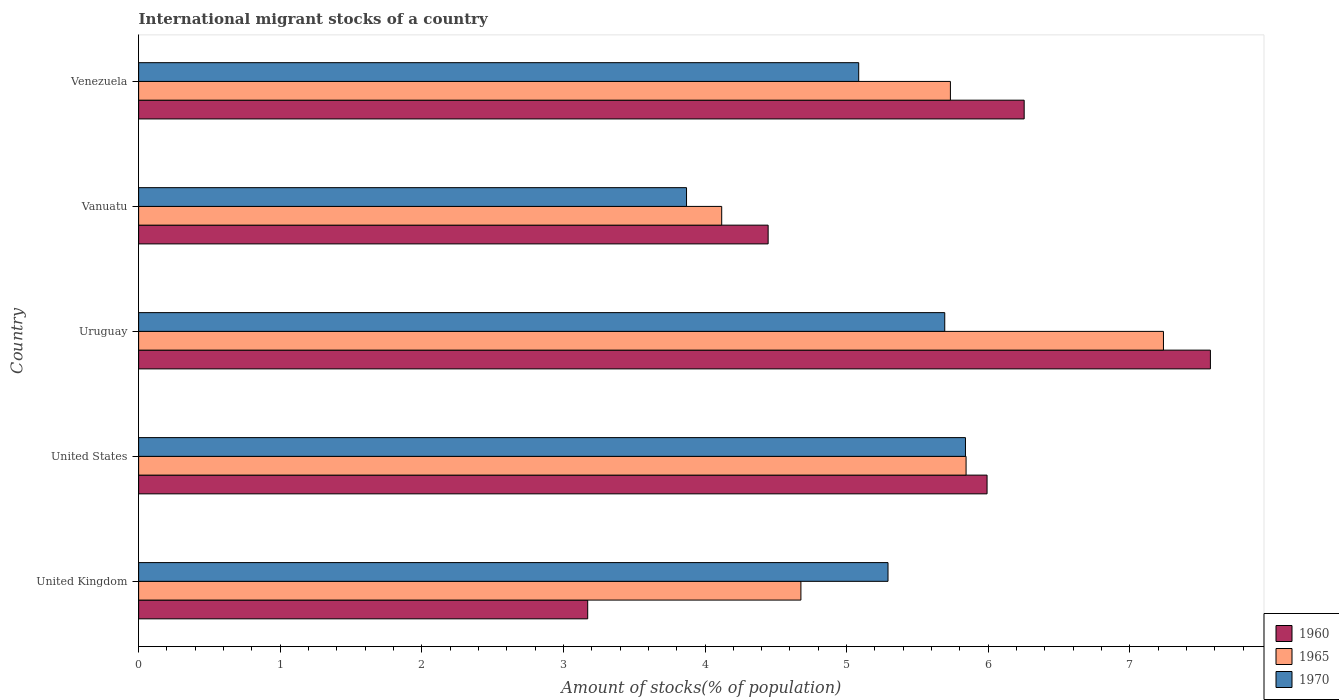How many different coloured bars are there?
Your answer should be very brief. 3. Are the number of bars per tick equal to the number of legend labels?
Your response must be concise. Yes. What is the label of the 5th group of bars from the top?
Offer a terse response. United Kingdom. What is the amount of stocks in in 1970 in Venezuela?
Your answer should be very brief. 5.09. Across all countries, what is the maximum amount of stocks in in 1960?
Keep it short and to the point. 7.57. Across all countries, what is the minimum amount of stocks in in 1965?
Offer a terse response. 4.12. In which country was the amount of stocks in in 1960 maximum?
Make the answer very short. Uruguay. In which country was the amount of stocks in in 1965 minimum?
Provide a succinct answer. Vanuatu. What is the total amount of stocks in in 1960 in the graph?
Make the answer very short. 27.43. What is the difference between the amount of stocks in in 1970 in United Kingdom and that in United States?
Give a very brief answer. -0.55. What is the difference between the amount of stocks in in 1965 in United Kingdom and the amount of stocks in in 1970 in Venezuela?
Your answer should be compact. -0.41. What is the average amount of stocks in in 1970 per country?
Provide a short and direct response. 5.16. What is the difference between the amount of stocks in in 1960 and amount of stocks in in 1970 in United States?
Keep it short and to the point. 0.15. In how many countries, is the amount of stocks in in 1965 greater than 0.6000000000000001 %?
Make the answer very short. 5. What is the ratio of the amount of stocks in in 1965 in United States to that in Uruguay?
Make the answer very short. 0.81. What is the difference between the highest and the second highest amount of stocks in in 1960?
Offer a very short reply. 1.32. What is the difference between the highest and the lowest amount of stocks in in 1960?
Keep it short and to the point. 4.4. In how many countries, is the amount of stocks in in 1965 greater than the average amount of stocks in in 1965 taken over all countries?
Your response must be concise. 3. Is the sum of the amount of stocks in in 1965 in United Kingdom and Venezuela greater than the maximum amount of stocks in in 1970 across all countries?
Provide a succinct answer. Yes. What does the 2nd bar from the top in Venezuela represents?
Provide a succinct answer. 1965. What does the 3rd bar from the bottom in Vanuatu represents?
Keep it short and to the point. 1970. Is it the case that in every country, the sum of the amount of stocks in in 1965 and amount of stocks in in 1970 is greater than the amount of stocks in in 1960?
Keep it short and to the point. Yes. How many countries are there in the graph?
Provide a succinct answer. 5. What is the difference between two consecutive major ticks on the X-axis?
Give a very brief answer. 1. Does the graph contain grids?
Your answer should be compact. No. What is the title of the graph?
Provide a short and direct response. International migrant stocks of a country. Does "2004" appear as one of the legend labels in the graph?
Provide a short and direct response. No. What is the label or title of the X-axis?
Provide a short and direct response. Amount of stocks(% of population). What is the label or title of the Y-axis?
Your answer should be very brief. Country. What is the Amount of stocks(% of population) in 1960 in United Kingdom?
Your response must be concise. 3.17. What is the Amount of stocks(% of population) of 1965 in United Kingdom?
Your response must be concise. 4.68. What is the Amount of stocks(% of population) in 1970 in United Kingdom?
Ensure brevity in your answer.  5.29. What is the Amount of stocks(% of population) of 1960 in United States?
Your answer should be very brief. 5.99. What is the Amount of stocks(% of population) of 1965 in United States?
Keep it short and to the point. 5.84. What is the Amount of stocks(% of population) in 1970 in United States?
Offer a terse response. 5.84. What is the Amount of stocks(% of population) in 1960 in Uruguay?
Ensure brevity in your answer.  7.57. What is the Amount of stocks(% of population) in 1965 in Uruguay?
Keep it short and to the point. 7.24. What is the Amount of stocks(% of population) of 1970 in Uruguay?
Offer a very short reply. 5.69. What is the Amount of stocks(% of population) of 1960 in Vanuatu?
Make the answer very short. 4.45. What is the Amount of stocks(% of population) of 1965 in Vanuatu?
Ensure brevity in your answer.  4.12. What is the Amount of stocks(% of population) of 1970 in Vanuatu?
Your answer should be compact. 3.87. What is the Amount of stocks(% of population) in 1960 in Venezuela?
Ensure brevity in your answer.  6.25. What is the Amount of stocks(% of population) of 1965 in Venezuela?
Offer a terse response. 5.73. What is the Amount of stocks(% of population) in 1970 in Venezuela?
Your answer should be very brief. 5.09. Across all countries, what is the maximum Amount of stocks(% of population) of 1960?
Your answer should be compact. 7.57. Across all countries, what is the maximum Amount of stocks(% of population) in 1965?
Your response must be concise. 7.24. Across all countries, what is the maximum Amount of stocks(% of population) of 1970?
Provide a succinct answer. 5.84. Across all countries, what is the minimum Amount of stocks(% of population) in 1960?
Make the answer very short. 3.17. Across all countries, what is the minimum Amount of stocks(% of population) in 1965?
Your answer should be compact. 4.12. Across all countries, what is the minimum Amount of stocks(% of population) of 1970?
Make the answer very short. 3.87. What is the total Amount of stocks(% of population) of 1960 in the graph?
Provide a short and direct response. 27.43. What is the total Amount of stocks(% of population) in 1965 in the graph?
Offer a terse response. 27.61. What is the total Amount of stocks(% of population) of 1970 in the graph?
Your response must be concise. 25.78. What is the difference between the Amount of stocks(% of population) in 1960 in United Kingdom and that in United States?
Your answer should be very brief. -2.82. What is the difference between the Amount of stocks(% of population) in 1965 in United Kingdom and that in United States?
Offer a very short reply. -1.17. What is the difference between the Amount of stocks(% of population) of 1970 in United Kingdom and that in United States?
Your response must be concise. -0.55. What is the difference between the Amount of stocks(% of population) in 1960 in United Kingdom and that in Uruguay?
Keep it short and to the point. -4.4. What is the difference between the Amount of stocks(% of population) in 1965 in United Kingdom and that in Uruguay?
Offer a terse response. -2.56. What is the difference between the Amount of stocks(% of population) of 1970 in United Kingdom and that in Uruguay?
Provide a short and direct response. -0.4. What is the difference between the Amount of stocks(% of population) in 1960 in United Kingdom and that in Vanuatu?
Your answer should be very brief. -1.27. What is the difference between the Amount of stocks(% of population) of 1965 in United Kingdom and that in Vanuatu?
Give a very brief answer. 0.56. What is the difference between the Amount of stocks(% of population) of 1970 in United Kingdom and that in Vanuatu?
Your response must be concise. 1.42. What is the difference between the Amount of stocks(% of population) in 1960 in United Kingdom and that in Venezuela?
Give a very brief answer. -3.08. What is the difference between the Amount of stocks(% of population) in 1965 in United Kingdom and that in Venezuela?
Your response must be concise. -1.06. What is the difference between the Amount of stocks(% of population) of 1970 in United Kingdom and that in Venezuela?
Make the answer very short. 0.21. What is the difference between the Amount of stocks(% of population) in 1960 in United States and that in Uruguay?
Your response must be concise. -1.58. What is the difference between the Amount of stocks(% of population) of 1965 in United States and that in Uruguay?
Give a very brief answer. -1.39. What is the difference between the Amount of stocks(% of population) of 1970 in United States and that in Uruguay?
Make the answer very short. 0.15. What is the difference between the Amount of stocks(% of population) in 1960 in United States and that in Vanuatu?
Keep it short and to the point. 1.55. What is the difference between the Amount of stocks(% of population) in 1965 in United States and that in Vanuatu?
Ensure brevity in your answer.  1.73. What is the difference between the Amount of stocks(% of population) in 1970 in United States and that in Vanuatu?
Provide a short and direct response. 1.97. What is the difference between the Amount of stocks(% of population) of 1960 in United States and that in Venezuela?
Keep it short and to the point. -0.26. What is the difference between the Amount of stocks(% of population) of 1965 in United States and that in Venezuela?
Provide a succinct answer. 0.11. What is the difference between the Amount of stocks(% of population) in 1970 in United States and that in Venezuela?
Offer a terse response. 0.75. What is the difference between the Amount of stocks(% of population) of 1960 in Uruguay and that in Vanuatu?
Make the answer very short. 3.12. What is the difference between the Amount of stocks(% of population) in 1965 in Uruguay and that in Vanuatu?
Give a very brief answer. 3.12. What is the difference between the Amount of stocks(% of population) of 1970 in Uruguay and that in Vanuatu?
Ensure brevity in your answer.  1.82. What is the difference between the Amount of stocks(% of population) in 1960 in Uruguay and that in Venezuela?
Keep it short and to the point. 1.32. What is the difference between the Amount of stocks(% of population) of 1965 in Uruguay and that in Venezuela?
Ensure brevity in your answer.  1.5. What is the difference between the Amount of stocks(% of population) of 1970 in Uruguay and that in Venezuela?
Your response must be concise. 0.61. What is the difference between the Amount of stocks(% of population) of 1960 in Vanuatu and that in Venezuela?
Ensure brevity in your answer.  -1.81. What is the difference between the Amount of stocks(% of population) in 1965 in Vanuatu and that in Venezuela?
Your answer should be compact. -1.62. What is the difference between the Amount of stocks(% of population) in 1970 in Vanuatu and that in Venezuela?
Provide a short and direct response. -1.22. What is the difference between the Amount of stocks(% of population) of 1960 in United Kingdom and the Amount of stocks(% of population) of 1965 in United States?
Ensure brevity in your answer.  -2.67. What is the difference between the Amount of stocks(% of population) in 1960 in United Kingdom and the Amount of stocks(% of population) in 1970 in United States?
Keep it short and to the point. -2.67. What is the difference between the Amount of stocks(% of population) of 1965 in United Kingdom and the Amount of stocks(% of population) of 1970 in United States?
Your response must be concise. -1.16. What is the difference between the Amount of stocks(% of population) of 1960 in United Kingdom and the Amount of stocks(% of population) of 1965 in Uruguay?
Your answer should be very brief. -4.07. What is the difference between the Amount of stocks(% of population) of 1960 in United Kingdom and the Amount of stocks(% of population) of 1970 in Uruguay?
Your response must be concise. -2.52. What is the difference between the Amount of stocks(% of population) in 1965 in United Kingdom and the Amount of stocks(% of population) in 1970 in Uruguay?
Offer a very short reply. -1.02. What is the difference between the Amount of stocks(% of population) of 1960 in United Kingdom and the Amount of stocks(% of population) of 1965 in Vanuatu?
Provide a succinct answer. -0.95. What is the difference between the Amount of stocks(% of population) of 1960 in United Kingdom and the Amount of stocks(% of population) of 1970 in Vanuatu?
Your answer should be compact. -0.7. What is the difference between the Amount of stocks(% of population) in 1965 in United Kingdom and the Amount of stocks(% of population) in 1970 in Vanuatu?
Your answer should be compact. 0.81. What is the difference between the Amount of stocks(% of population) of 1960 in United Kingdom and the Amount of stocks(% of population) of 1965 in Venezuela?
Make the answer very short. -2.56. What is the difference between the Amount of stocks(% of population) of 1960 in United Kingdom and the Amount of stocks(% of population) of 1970 in Venezuela?
Keep it short and to the point. -1.91. What is the difference between the Amount of stocks(% of population) in 1965 in United Kingdom and the Amount of stocks(% of population) in 1970 in Venezuela?
Keep it short and to the point. -0.41. What is the difference between the Amount of stocks(% of population) in 1960 in United States and the Amount of stocks(% of population) in 1965 in Uruguay?
Provide a succinct answer. -1.25. What is the difference between the Amount of stocks(% of population) of 1960 in United States and the Amount of stocks(% of population) of 1970 in Uruguay?
Your answer should be very brief. 0.3. What is the difference between the Amount of stocks(% of population) in 1965 in United States and the Amount of stocks(% of population) in 1970 in Uruguay?
Offer a terse response. 0.15. What is the difference between the Amount of stocks(% of population) in 1960 in United States and the Amount of stocks(% of population) in 1965 in Vanuatu?
Your response must be concise. 1.87. What is the difference between the Amount of stocks(% of population) of 1960 in United States and the Amount of stocks(% of population) of 1970 in Vanuatu?
Your answer should be very brief. 2.12. What is the difference between the Amount of stocks(% of population) of 1965 in United States and the Amount of stocks(% of population) of 1970 in Vanuatu?
Make the answer very short. 1.97. What is the difference between the Amount of stocks(% of population) in 1960 in United States and the Amount of stocks(% of population) in 1965 in Venezuela?
Provide a short and direct response. 0.26. What is the difference between the Amount of stocks(% of population) in 1960 in United States and the Amount of stocks(% of population) in 1970 in Venezuela?
Keep it short and to the point. 0.91. What is the difference between the Amount of stocks(% of population) in 1965 in United States and the Amount of stocks(% of population) in 1970 in Venezuela?
Your response must be concise. 0.76. What is the difference between the Amount of stocks(% of population) of 1960 in Uruguay and the Amount of stocks(% of population) of 1965 in Vanuatu?
Your response must be concise. 3.45. What is the difference between the Amount of stocks(% of population) in 1960 in Uruguay and the Amount of stocks(% of population) in 1970 in Vanuatu?
Ensure brevity in your answer.  3.7. What is the difference between the Amount of stocks(% of population) of 1965 in Uruguay and the Amount of stocks(% of population) of 1970 in Vanuatu?
Provide a succinct answer. 3.37. What is the difference between the Amount of stocks(% of population) in 1960 in Uruguay and the Amount of stocks(% of population) in 1965 in Venezuela?
Your answer should be compact. 1.84. What is the difference between the Amount of stocks(% of population) in 1960 in Uruguay and the Amount of stocks(% of population) in 1970 in Venezuela?
Ensure brevity in your answer.  2.48. What is the difference between the Amount of stocks(% of population) of 1965 in Uruguay and the Amount of stocks(% of population) of 1970 in Venezuela?
Your answer should be very brief. 2.15. What is the difference between the Amount of stocks(% of population) in 1960 in Vanuatu and the Amount of stocks(% of population) in 1965 in Venezuela?
Offer a terse response. -1.29. What is the difference between the Amount of stocks(% of population) of 1960 in Vanuatu and the Amount of stocks(% of population) of 1970 in Venezuela?
Make the answer very short. -0.64. What is the difference between the Amount of stocks(% of population) in 1965 in Vanuatu and the Amount of stocks(% of population) in 1970 in Venezuela?
Offer a very short reply. -0.97. What is the average Amount of stocks(% of population) in 1960 per country?
Offer a very short reply. 5.49. What is the average Amount of stocks(% of population) of 1965 per country?
Your answer should be compact. 5.52. What is the average Amount of stocks(% of population) of 1970 per country?
Your response must be concise. 5.16. What is the difference between the Amount of stocks(% of population) of 1960 and Amount of stocks(% of population) of 1965 in United Kingdom?
Provide a short and direct response. -1.51. What is the difference between the Amount of stocks(% of population) of 1960 and Amount of stocks(% of population) of 1970 in United Kingdom?
Give a very brief answer. -2.12. What is the difference between the Amount of stocks(% of population) of 1965 and Amount of stocks(% of population) of 1970 in United Kingdom?
Offer a very short reply. -0.62. What is the difference between the Amount of stocks(% of population) of 1960 and Amount of stocks(% of population) of 1965 in United States?
Your answer should be compact. 0.15. What is the difference between the Amount of stocks(% of population) of 1960 and Amount of stocks(% of population) of 1970 in United States?
Offer a terse response. 0.15. What is the difference between the Amount of stocks(% of population) in 1965 and Amount of stocks(% of population) in 1970 in United States?
Keep it short and to the point. 0. What is the difference between the Amount of stocks(% of population) in 1960 and Amount of stocks(% of population) in 1965 in Uruguay?
Provide a succinct answer. 0.33. What is the difference between the Amount of stocks(% of population) of 1960 and Amount of stocks(% of population) of 1970 in Uruguay?
Your response must be concise. 1.88. What is the difference between the Amount of stocks(% of population) of 1965 and Amount of stocks(% of population) of 1970 in Uruguay?
Keep it short and to the point. 1.54. What is the difference between the Amount of stocks(% of population) in 1960 and Amount of stocks(% of population) in 1965 in Vanuatu?
Offer a very short reply. 0.33. What is the difference between the Amount of stocks(% of population) of 1960 and Amount of stocks(% of population) of 1970 in Vanuatu?
Your answer should be compact. 0.58. What is the difference between the Amount of stocks(% of population) in 1965 and Amount of stocks(% of population) in 1970 in Vanuatu?
Provide a succinct answer. 0.25. What is the difference between the Amount of stocks(% of population) in 1960 and Amount of stocks(% of population) in 1965 in Venezuela?
Ensure brevity in your answer.  0.52. What is the difference between the Amount of stocks(% of population) of 1960 and Amount of stocks(% of population) of 1970 in Venezuela?
Your response must be concise. 1.17. What is the difference between the Amount of stocks(% of population) of 1965 and Amount of stocks(% of population) of 1970 in Venezuela?
Offer a terse response. 0.65. What is the ratio of the Amount of stocks(% of population) of 1960 in United Kingdom to that in United States?
Make the answer very short. 0.53. What is the ratio of the Amount of stocks(% of population) of 1965 in United Kingdom to that in United States?
Provide a succinct answer. 0.8. What is the ratio of the Amount of stocks(% of population) in 1970 in United Kingdom to that in United States?
Make the answer very short. 0.91. What is the ratio of the Amount of stocks(% of population) in 1960 in United Kingdom to that in Uruguay?
Offer a terse response. 0.42. What is the ratio of the Amount of stocks(% of population) of 1965 in United Kingdom to that in Uruguay?
Offer a very short reply. 0.65. What is the ratio of the Amount of stocks(% of population) in 1970 in United Kingdom to that in Uruguay?
Make the answer very short. 0.93. What is the ratio of the Amount of stocks(% of population) in 1960 in United Kingdom to that in Vanuatu?
Provide a short and direct response. 0.71. What is the ratio of the Amount of stocks(% of population) of 1965 in United Kingdom to that in Vanuatu?
Your answer should be compact. 1.14. What is the ratio of the Amount of stocks(% of population) of 1970 in United Kingdom to that in Vanuatu?
Keep it short and to the point. 1.37. What is the ratio of the Amount of stocks(% of population) in 1960 in United Kingdom to that in Venezuela?
Give a very brief answer. 0.51. What is the ratio of the Amount of stocks(% of population) in 1965 in United Kingdom to that in Venezuela?
Make the answer very short. 0.82. What is the ratio of the Amount of stocks(% of population) in 1970 in United Kingdom to that in Venezuela?
Offer a terse response. 1.04. What is the ratio of the Amount of stocks(% of population) in 1960 in United States to that in Uruguay?
Your answer should be compact. 0.79. What is the ratio of the Amount of stocks(% of population) of 1965 in United States to that in Uruguay?
Offer a terse response. 0.81. What is the ratio of the Amount of stocks(% of population) in 1970 in United States to that in Uruguay?
Offer a very short reply. 1.03. What is the ratio of the Amount of stocks(% of population) in 1960 in United States to that in Vanuatu?
Give a very brief answer. 1.35. What is the ratio of the Amount of stocks(% of population) of 1965 in United States to that in Vanuatu?
Provide a short and direct response. 1.42. What is the ratio of the Amount of stocks(% of population) of 1970 in United States to that in Vanuatu?
Offer a very short reply. 1.51. What is the ratio of the Amount of stocks(% of population) in 1960 in United States to that in Venezuela?
Your answer should be very brief. 0.96. What is the ratio of the Amount of stocks(% of population) in 1965 in United States to that in Venezuela?
Provide a succinct answer. 1.02. What is the ratio of the Amount of stocks(% of population) in 1970 in United States to that in Venezuela?
Offer a terse response. 1.15. What is the ratio of the Amount of stocks(% of population) in 1960 in Uruguay to that in Vanuatu?
Ensure brevity in your answer.  1.7. What is the ratio of the Amount of stocks(% of population) in 1965 in Uruguay to that in Vanuatu?
Offer a very short reply. 1.76. What is the ratio of the Amount of stocks(% of population) of 1970 in Uruguay to that in Vanuatu?
Your response must be concise. 1.47. What is the ratio of the Amount of stocks(% of population) in 1960 in Uruguay to that in Venezuela?
Keep it short and to the point. 1.21. What is the ratio of the Amount of stocks(% of population) in 1965 in Uruguay to that in Venezuela?
Give a very brief answer. 1.26. What is the ratio of the Amount of stocks(% of population) in 1970 in Uruguay to that in Venezuela?
Make the answer very short. 1.12. What is the ratio of the Amount of stocks(% of population) in 1960 in Vanuatu to that in Venezuela?
Offer a terse response. 0.71. What is the ratio of the Amount of stocks(% of population) of 1965 in Vanuatu to that in Venezuela?
Make the answer very short. 0.72. What is the ratio of the Amount of stocks(% of population) in 1970 in Vanuatu to that in Venezuela?
Ensure brevity in your answer.  0.76. What is the difference between the highest and the second highest Amount of stocks(% of population) in 1960?
Make the answer very short. 1.32. What is the difference between the highest and the second highest Amount of stocks(% of population) of 1965?
Keep it short and to the point. 1.39. What is the difference between the highest and the second highest Amount of stocks(% of population) of 1970?
Give a very brief answer. 0.15. What is the difference between the highest and the lowest Amount of stocks(% of population) of 1960?
Keep it short and to the point. 4.4. What is the difference between the highest and the lowest Amount of stocks(% of population) of 1965?
Give a very brief answer. 3.12. What is the difference between the highest and the lowest Amount of stocks(% of population) in 1970?
Provide a short and direct response. 1.97. 